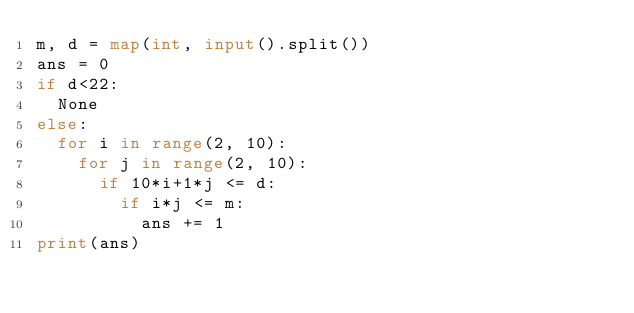Convert code to text. <code><loc_0><loc_0><loc_500><loc_500><_Python_>m, d = map(int, input().split())
ans = 0
if d<22:
  None
else:
  for i in range(2, 10):
    for j in range(2, 10):
      if 10*i+1*j <= d:
      	if i*j <= m:
        	ans += 1
print(ans)</code> 